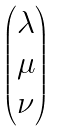<formula> <loc_0><loc_0><loc_500><loc_500>\begin{pmatrix} \lambda \\ \mu \\ \nu \end{pmatrix}</formula> 